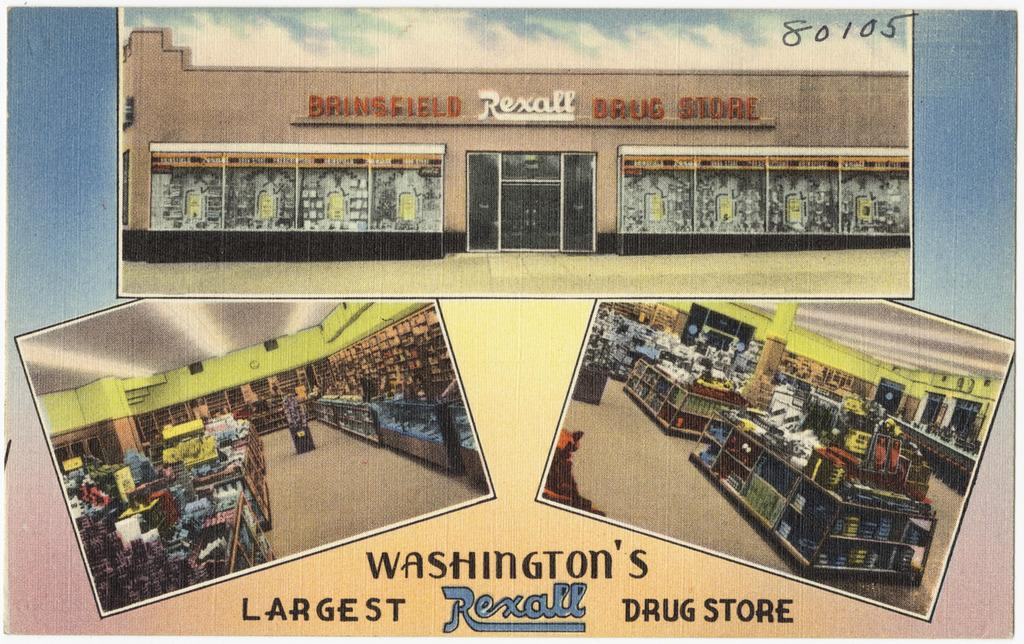<image>
Relay a brief, clear account of the picture shown. Three postcards on top of one another and the word's "Washington's Rexall" under. 